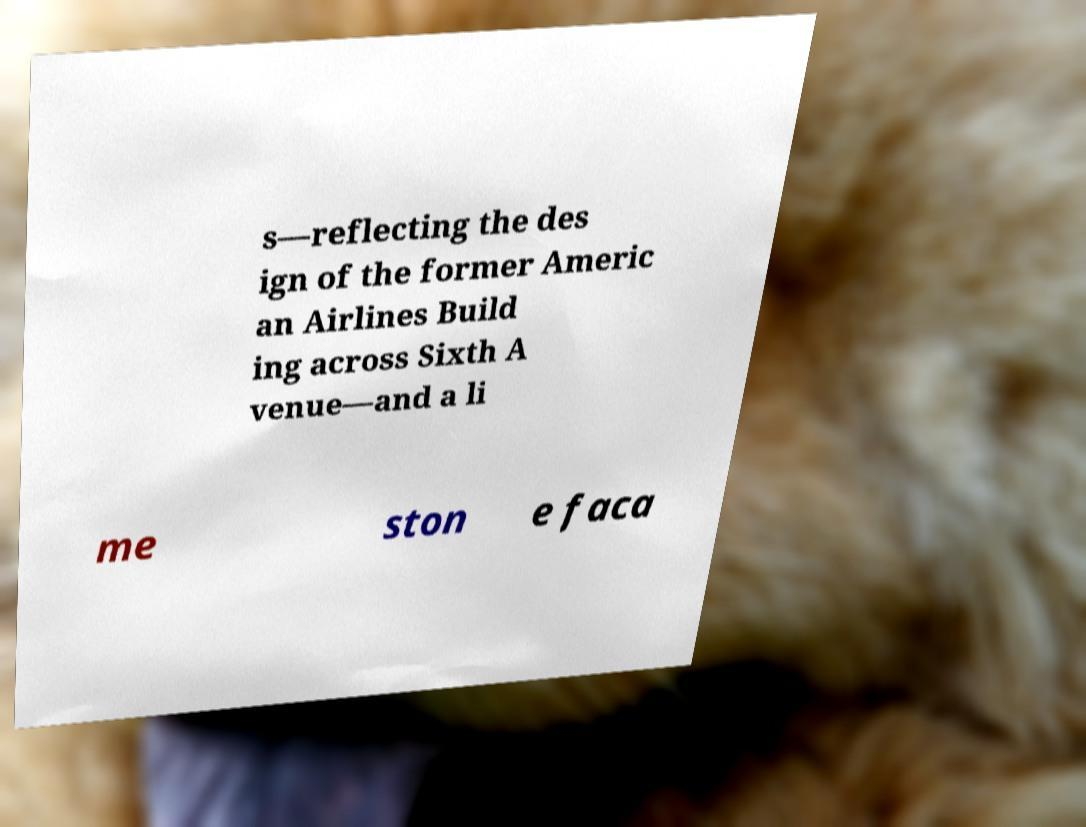Could you extract and type out the text from this image? s—reflecting the des ign of the former Americ an Airlines Build ing across Sixth A venue—and a li me ston e faca 